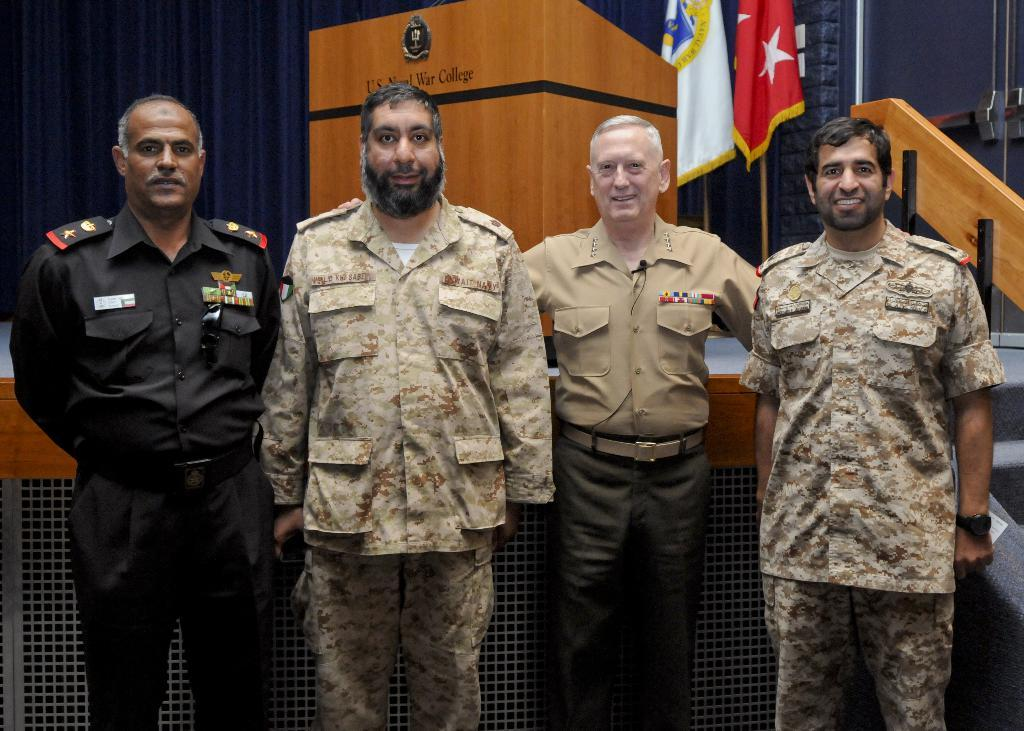What is the main subject of the image? The main subject of the image is men standing in the center. What can be seen in the background of the image? In the background of the image, there is a desk, flags, a curtain associated with a window, stairs, and a wall. What idea did the men come up with while running in the image? There is no indication in the image that the men are running or discussing any ideas. 